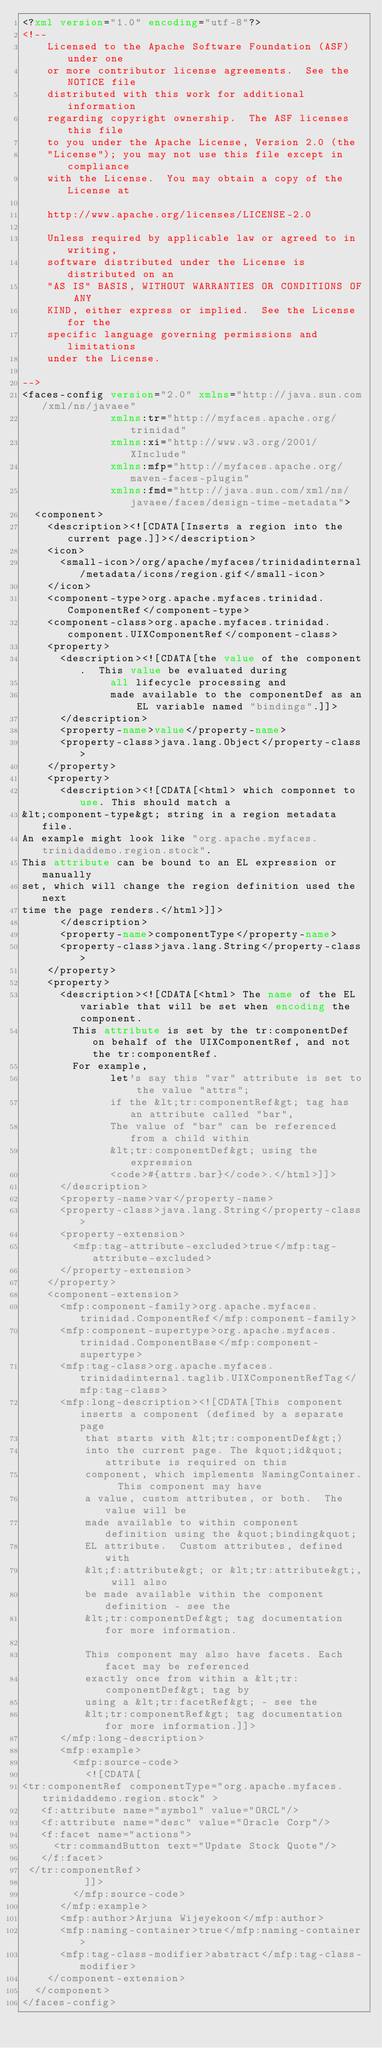Convert code to text. <code><loc_0><loc_0><loc_500><loc_500><_XML_><?xml version="1.0" encoding="utf-8"?>
<!--
    Licensed to the Apache Software Foundation (ASF) under one
    or more contributor license agreements.  See the NOTICE file
    distributed with this work for additional information
    regarding copyright ownership.  The ASF licenses this file
    to you under the Apache License, Version 2.0 (the
    "License"); you may not use this file except in compliance
    with the License.  You may obtain a copy of the License at

    http://www.apache.org/licenses/LICENSE-2.0

    Unless required by applicable law or agreed to in writing,
    software distributed under the License is distributed on an
    "AS IS" BASIS, WITHOUT WARRANTIES OR CONDITIONS OF ANY
    KIND, either express or implied.  See the License for the
    specific language governing permissions and limitations
    under the License.

-->
<faces-config version="2.0" xmlns="http://java.sun.com/xml/ns/javaee"
              xmlns:tr="http://myfaces.apache.org/trinidad"
              xmlns:xi="http://www.w3.org/2001/XInclude"
              xmlns:mfp="http://myfaces.apache.org/maven-faces-plugin"
              xmlns:fmd="http://java.sun.com/xml/ns/javaee/faces/design-time-metadata">
  <component>
    <description><![CDATA[Inserts a region into the current page.]]></description>
    <icon>
      <small-icon>/org/apache/myfaces/trinidadinternal/metadata/icons/region.gif</small-icon>
    </icon>
    <component-type>org.apache.myfaces.trinidad.ComponentRef</component-type>
    <component-class>org.apache.myfaces.trinidad.component.UIXComponentRef</component-class>
    <property>
      <description><![CDATA[the value of the component.  This value be evaluated during
              all lifecycle processing and
              made available to the componentDef as an EL variable named "bindings".]]>
      </description>
      <property-name>value</property-name>
      <property-class>java.lang.Object</property-class>
    </property>
    <property>
      <description><![CDATA[<html> which componnet to use. This should match a
&lt;component-type&gt; string in a region metadata file.
An example might look like "org.apache.myfaces.trinidaddemo.region.stock".
This attribute can be bound to an EL expression or manually
set, which will change the region definition used the next
time the page renders.</html>]]>
      </description>
      <property-name>componentType</property-name>
      <property-class>java.lang.String</property-class>
    </property>
    <property>
      <description><![CDATA[<html> The name of the EL variable that will be set when encoding the component.
        This attribute is set by the tr:componentDef on behalf of the UIXComponentRef, and not the tr:componentRef.
        For example,
              let's say this "var" attribute is set to the value "attrs";
              if the &lt;tr:componentRef&gt; tag has an attribute called "bar",
              The value of "bar" can be referenced from a child within
              &lt;tr:componentDef&gt; using the expression
              <code>#{attrs.bar}</code>.</html>]]>
      </description>
      <property-name>var</property-name>
      <property-class>java.lang.String</property-class>
      <property-extension>
        <mfp:tag-attribute-excluded>true</mfp:tag-attribute-excluded>
      </property-extension>
    </property>
    <component-extension>
      <mfp:component-family>org.apache.myfaces.trinidad.ComponentRef</mfp:component-family>
      <mfp:component-supertype>org.apache.myfaces.trinidad.ComponentBase</mfp:component-supertype>
      <mfp:tag-class>org.apache.myfaces.trinidadinternal.taglib.UIXComponentRefTag</mfp:tag-class>
      <mfp:long-description><![CDATA[This component inserts a component (defined by a separate page
          that starts with &lt;tr:componentDef&gt;)
          into the current page. The &quot;id&quot; attribute is required on this
          component, which implements NamingContainer.  This component may have
          a value, custom attributes, or both.  The value will be
          made available to within component definition using the &quot;binding&quot;
          EL attribute.  Custom attributes, defined with
          &lt;f:attribute&gt; or &lt;tr:attribute&gt;, will also
          be made available within the component definition - see the
          &lt;tr:componentDef&gt; tag documentation for more information.

          This component may also have facets. Each facet may be referenced
          exactly once from within a &lt;tr:componentDef&gt; tag by
          using a &lt;tr:facetRef&gt; - see the
          &lt;tr:componentRef&gt; tag documentation for more information.]]>
      </mfp:long-description>
      <mfp:example>
        <mfp:source-code>
          <![CDATA[
<tr:componentRef componentType="org.apache.myfaces.trinidaddemo.region.stock" >
   <f:attribute name="symbol" value="ORCL"/>
   <f:attribute name="desc" value="Oracle Corp"/>
   <f:facet name="actions">
     <tr:commandButton text="Update Stock Quote"/>
   </f:facet>
 </tr:componentRef>
          ]]>
        </mfp:source-code>
      </mfp:example>
      <mfp:author>Arjuna Wijeyekoon</mfp:author>
      <mfp:naming-container>true</mfp:naming-container>
      <mfp:tag-class-modifier>abstract</mfp:tag-class-modifier>
    </component-extension>
  </component>
</faces-config>



</code> 